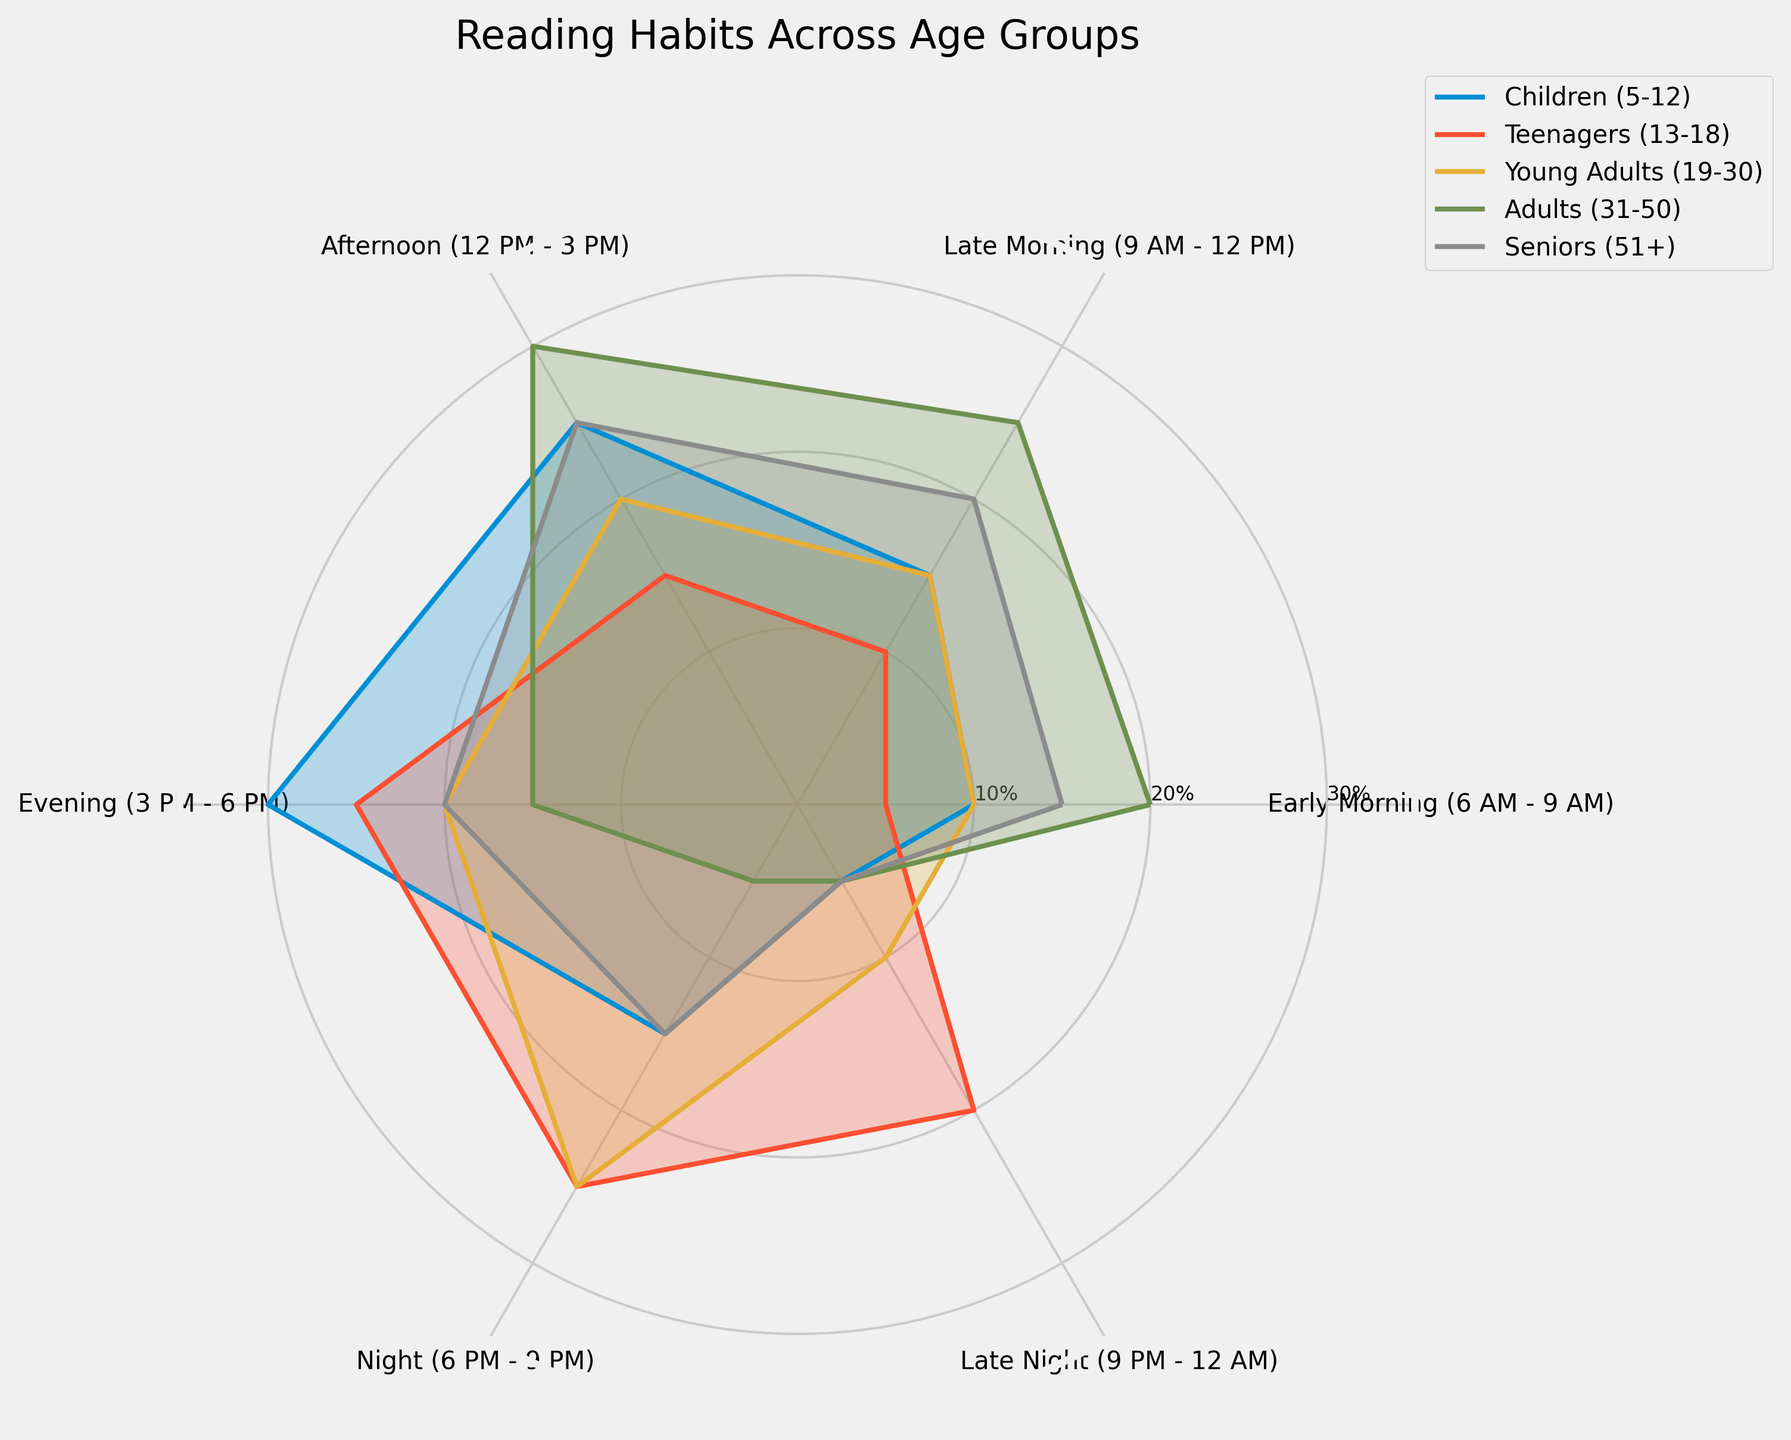What is the title of the chart? The title of the chart is located at the top and reads "Reading Habits Across Age Groups."
Answer: Reading Habits Across Age Groups Which age group has the highest reading percentage in the Afternoon (12 PM - 3 PM)? By looking at the values in the Afternoon section of each group, Children, Teenagers, Young Adults, Adults, and Seniors have reading percentages of 25, 15, 20, 30, and 25 respectively. The highest among these is 30 for Adults.
Answer: Adults (31-50) What is the average reading percentage during Early Morning (6 AM - 9 AM) across all age groups? Sum the values of Early Morning for each age group: 10 (Children) + 5 (Teenagers) + 10 (Young Adults) + 20 (Adults) + 15 (Seniors), which equals 60. Divide by the number of groups, which is 5. The average is 60/5 = 12.
Answer: 12 Which age group shows a similar reading pattern in both Early Morning (6 AM - 9 AM) and Late Night (9 PM - 12 AM)? Observe the Early Morning and Late Night values for each group: Children (10, 5), Teenagers (5, 20), Young Adults (10, 10), Adults (20, 5), Seniors (15, 5). Young Adults are the closest with values (10, 10).
Answer: Young Adults (19-30) Are there any age groups whose highest reading time is in the Evening (3 PM - 6 PM)? By examining the plot, Children have their highest reading percentage in the Evening (30), other groups do not have their peaks during this time.
Answer: Yes, Children (5-12) Which time of day do Seniors (51+) read the most? Look at the values for each time block for Seniors: Early Morning (15), Late Morning (20), Afternoon (25), Evening (20), Night (15), and Late Night (5). The highest value is in the Afternoon, with 25%.
Answer: Afternoon (12 PM - 3 PM) Compare the reading percentages of Teenagers (13-18) and Young Adults (19-30) during Night (6 PM - 9 PM). Who reads more and by how much? Teenagers have a reading percentage of 25, while Young Adults have 25. Both read equally during Night with no difference.
Answer: Equal, 0% difference Considering all age groups, which time of day generally has the highest reading percentage? By analyzing the trends and observing the peaks in each age group, Afternoon (12 PM - 3 PM) has the highest reading percentages collectively across the groups.
Answer: Afternoon (12 PM - 3 PM) Which age group shows the least variability in their reading habits across different times of day? To determine variability, one can compare the range of percentages for each age group. Young Adults (values: 10, 15, 20, 20, 25, 10) have a range of 15, which is the lowest compared to other groups.
Answer: Young Adults (19-30) 